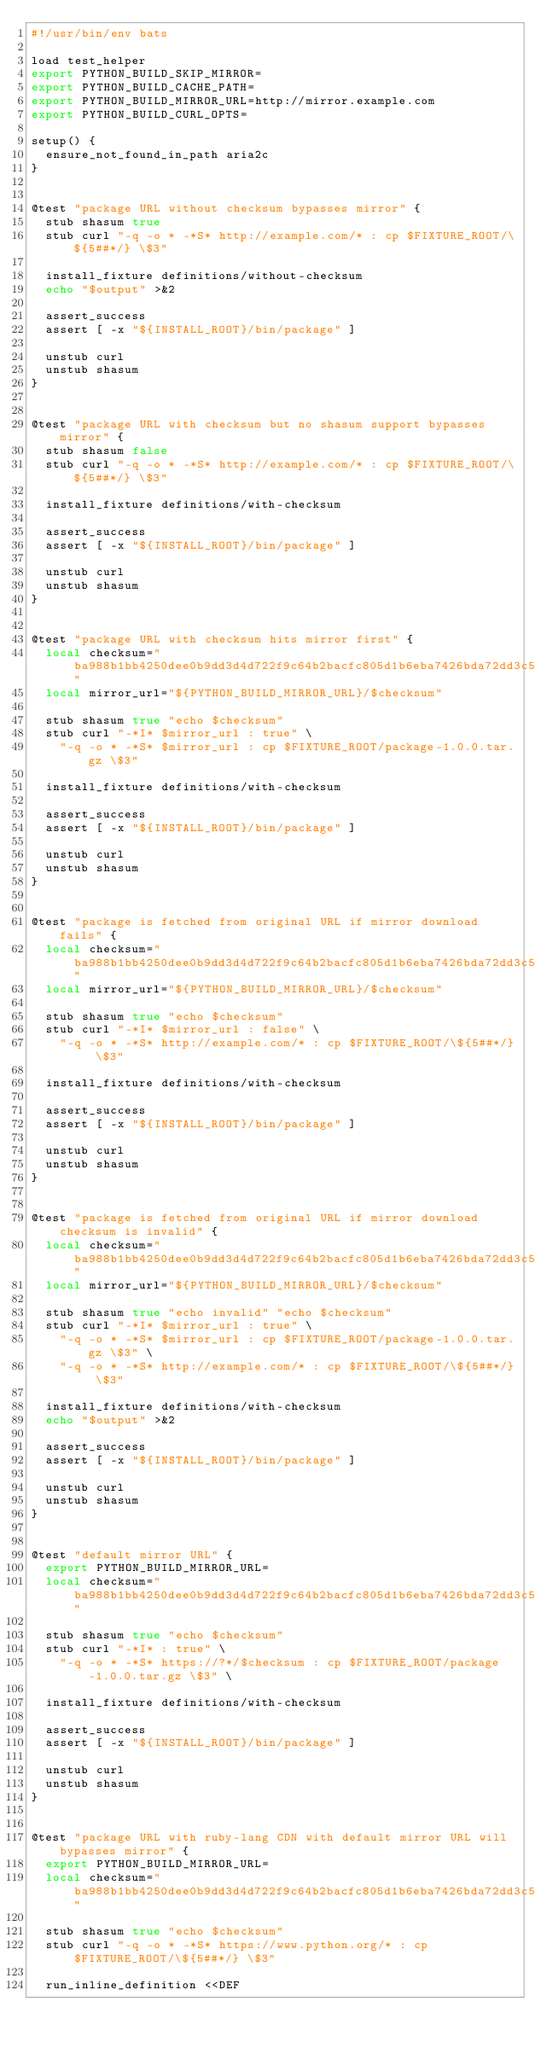Convert code to text. <code><loc_0><loc_0><loc_500><loc_500><_Bash_>#!/usr/bin/env bats

load test_helper
export PYTHON_BUILD_SKIP_MIRROR=
export PYTHON_BUILD_CACHE_PATH=
export PYTHON_BUILD_MIRROR_URL=http://mirror.example.com
export PYTHON_BUILD_CURL_OPTS=

setup() {
  ensure_not_found_in_path aria2c
}


@test "package URL without checksum bypasses mirror" {
  stub shasum true
  stub curl "-q -o * -*S* http://example.com/* : cp $FIXTURE_ROOT/\${5##*/} \$3"

  install_fixture definitions/without-checksum
  echo "$output" >&2

  assert_success
  assert [ -x "${INSTALL_ROOT}/bin/package" ]

  unstub curl
  unstub shasum
}


@test "package URL with checksum but no shasum support bypasses mirror" {
  stub shasum false
  stub curl "-q -o * -*S* http://example.com/* : cp $FIXTURE_ROOT/\${5##*/} \$3"

  install_fixture definitions/with-checksum

  assert_success
  assert [ -x "${INSTALL_ROOT}/bin/package" ]

  unstub curl
  unstub shasum
}


@test "package URL with checksum hits mirror first" {
  local checksum="ba988b1bb4250dee0b9dd3d4d722f9c64b2bacfc805d1b6eba7426bda72dd3c5"
  local mirror_url="${PYTHON_BUILD_MIRROR_URL}/$checksum"

  stub shasum true "echo $checksum"
  stub curl "-*I* $mirror_url : true" \
    "-q -o * -*S* $mirror_url : cp $FIXTURE_ROOT/package-1.0.0.tar.gz \$3"

  install_fixture definitions/with-checksum

  assert_success
  assert [ -x "${INSTALL_ROOT}/bin/package" ]

  unstub curl
  unstub shasum
}


@test "package is fetched from original URL if mirror download fails" {
  local checksum="ba988b1bb4250dee0b9dd3d4d722f9c64b2bacfc805d1b6eba7426bda72dd3c5"
  local mirror_url="${PYTHON_BUILD_MIRROR_URL}/$checksum"

  stub shasum true "echo $checksum"
  stub curl "-*I* $mirror_url : false" \
    "-q -o * -*S* http://example.com/* : cp $FIXTURE_ROOT/\${5##*/} \$3"

  install_fixture definitions/with-checksum

  assert_success
  assert [ -x "${INSTALL_ROOT}/bin/package" ]

  unstub curl
  unstub shasum
}


@test "package is fetched from original URL if mirror download checksum is invalid" {
  local checksum="ba988b1bb4250dee0b9dd3d4d722f9c64b2bacfc805d1b6eba7426bda72dd3c5"
  local mirror_url="${PYTHON_BUILD_MIRROR_URL}/$checksum"

  stub shasum true "echo invalid" "echo $checksum"
  stub curl "-*I* $mirror_url : true" \
    "-q -o * -*S* $mirror_url : cp $FIXTURE_ROOT/package-1.0.0.tar.gz \$3" \
    "-q -o * -*S* http://example.com/* : cp $FIXTURE_ROOT/\${5##*/} \$3"

  install_fixture definitions/with-checksum
  echo "$output" >&2

  assert_success
  assert [ -x "${INSTALL_ROOT}/bin/package" ]

  unstub curl
  unstub shasum
}


@test "default mirror URL" {
  export PYTHON_BUILD_MIRROR_URL=
  local checksum="ba988b1bb4250dee0b9dd3d4d722f9c64b2bacfc805d1b6eba7426bda72dd3c5"

  stub shasum true "echo $checksum"
  stub curl "-*I* : true" \
    "-q -o * -*S* https://?*/$checksum : cp $FIXTURE_ROOT/package-1.0.0.tar.gz \$3" \

  install_fixture definitions/with-checksum

  assert_success
  assert [ -x "${INSTALL_ROOT}/bin/package" ]

  unstub curl
  unstub shasum
}


@test "package URL with ruby-lang CDN with default mirror URL will bypasses mirror" {
  export PYTHON_BUILD_MIRROR_URL=
  local checksum="ba988b1bb4250dee0b9dd3d4d722f9c64b2bacfc805d1b6eba7426bda72dd3c5"

  stub shasum true "echo $checksum"
  stub curl "-q -o * -*S* https://www.python.org/* : cp $FIXTURE_ROOT/\${5##*/} \$3"

  run_inline_definition <<DEF</code> 